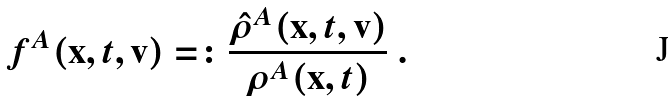<formula> <loc_0><loc_0><loc_500><loc_500>f ^ { A } ( \mathbf x , t , \mathbf v ) = \colon \frac { \hat { \rho } ^ { A } ( \mathbf x , t , \mathbf v ) } { \rho ^ { A } ( \mathbf x , t ) } \ .</formula> 